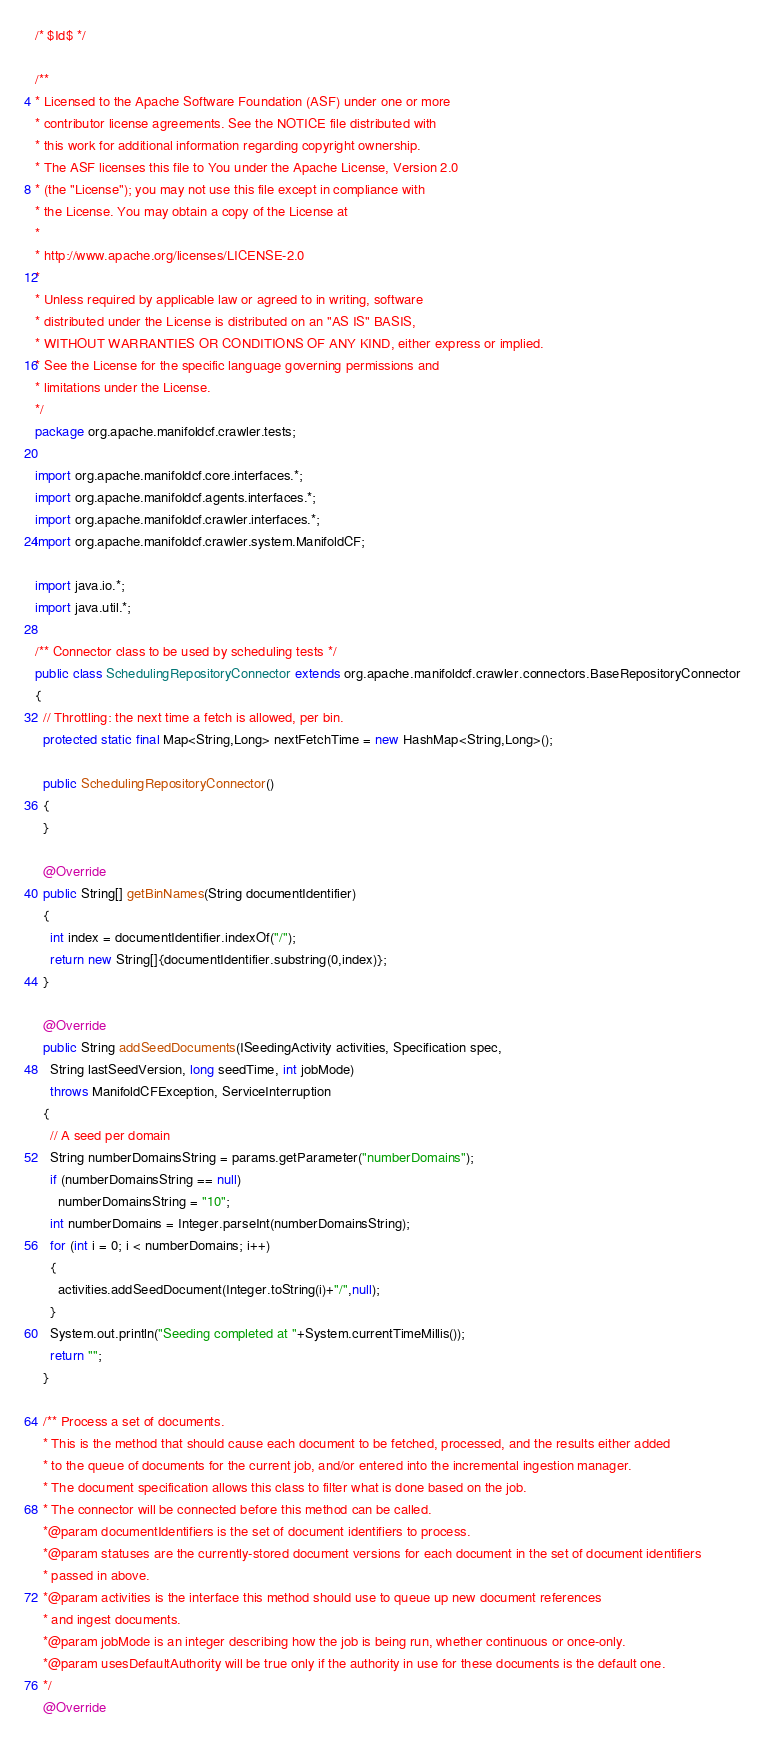Convert code to text. <code><loc_0><loc_0><loc_500><loc_500><_Java_>/* $Id$ */

/**
* Licensed to the Apache Software Foundation (ASF) under one or more
* contributor license agreements. See the NOTICE file distributed with
* this work for additional information regarding copyright ownership.
* The ASF licenses this file to You under the Apache License, Version 2.0
* (the "License"); you may not use this file except in compliance with
* the License. You may obtain a copy of the License at
*
* http://www.apache.org/licenses/LICENSE-2.0
*
* Unless required by applicable law or agreed to in writing, software
* distributed under the License is distributed on an "AS IS" BASIS,
* WITHOUT WARRANTIES OR CONDITIONS OF ANY KIND, either express or implied.
* See the License for the specific language governing permissions and
* limitations under the License.
*/
package org.apache.manifoldcf.crawler.tests;

import org.apache.manifoldcf.core.interfaces.*;
import org.apache.manifoldcf.agents.interfaces.*;
import org.apache.manifoldcf.crawler.interfaces.*;
import org.apache.manifoldcf.crawler.system.ManifoldCF;

import java.io.*;
import java.util.*;

/** Connector class to be used by scheduling tests */
public class SchedulingRepositoryConnector extends org.apache.manifoldcf.crawler.connectors.BaseRepositoryConnector
{
  // Throttling: the next time a fetch is allowed, per bin.
  protected static final Map<String,Long> nextFetchTime = new HashMap<String,Long>();

  public SchedulingRepositoryConnector()
  {
  }

  @Override
  public String[] getBinNames(String documentIdentifier)
  {
    int index = documentIdentifier.indexOf("/");
    return new String[]{documentIdentifier.substring(0,index)};
  }

  @Override
  public String addSeedDocuments(ISeedingActivity activities, Specification spec,
    String lastSeedVersion, long seedTime, int jobMode)
    throws ManifoldCFException, ServiceInterruption
  {
    // A seed per domain
    String numberDomainsString = params.getParameter("numberDomains");
    if (numberDomainsString == null)
      numberDomainsString = "10";
    int numberDomains = Integer.parseInt(numberDomainsString);
    for (int i = 0; i < numberDomains; i++)
    {
      activities.addSeedDocument(Integer.toString(i)+"/",null);
    }
    System.out.println("Seeding completed at "+System.currentTimeMillis());
    return "";
  }
  
  /** Process a set of documents.
  * This is the method that should cause each document to be fetched, processed, and the results either added
  * to the queue of documents for the current job, and/or entered into the incremental ingestion manager.
  * The document specification allows this class to filter what is done based on the job.
  * The connector will be connected before this method can be called.
  *@param documentIdentifiers is the set of document identifiers to process.
  *@param statuses are the currently-stored document versions for each document in the set of document identifiers
  * passed in above.
  *@param activities is the interface this method should use to queue up new document references
  * and ingest documents.
  *@param jobMode is an integer describing how the job is being run, whether continuous or once-only.
  *@param usesDefaultAuthority will be true only if the authority in use for these documents is the default one.
  */
  @Override</code> 